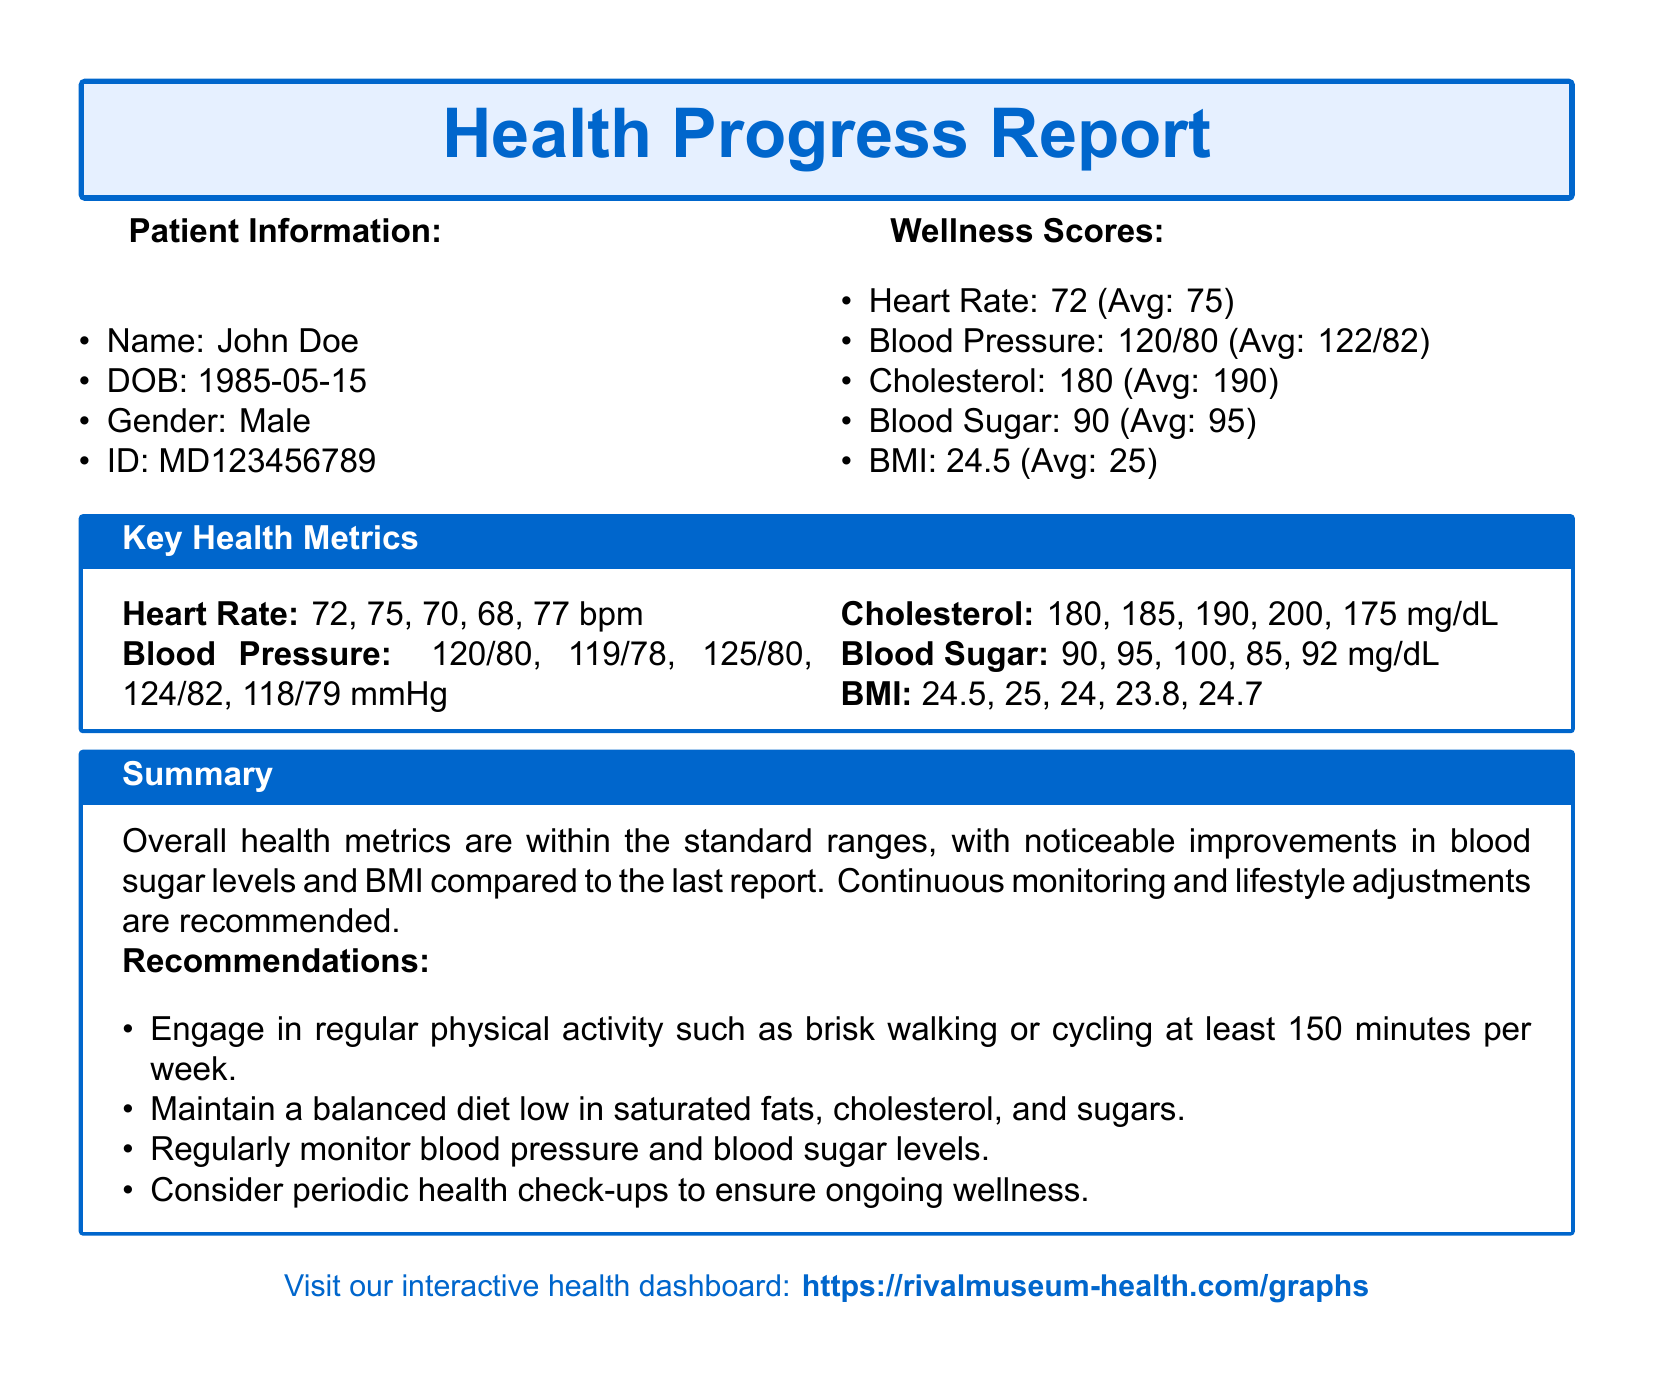What is the patient's name? The patient's name is explicitly stated in the patient information section of the document.
Answer: John Doe What is the patient's date of birth? The date of birth is clearly mentioned in the patient information section.
Answer: 1985-05-15 What is the average heart rate? The average heart rate is provided next to the individual heart rate metric in the wellness scores section.
Answer: 75 What is the cholesterol level? The cholesterol level is given in the wellness scores section of the document.
Answer: 180 Which health metric saw noticeable improvement? The summary section indicates which metrics have improved, requiring reasoning from the information given.
Answer: Blood sugar levels What is recommended physical activity? The recommendations for physical activity are listed in the summary section.
Answer: 150 minutes per week What is the patient's BMI? The BMI is included in the wellness scores section of the report.
Answer: 24.5 What is the blood pressure measurement? The blood pressure reading is noted in the wellness scores section.
Answer: 120/80 What should be monitored regularly? The recommendations section emphasizes the importance of monitoring specific health metrics.
Answer: Blood pressure and blood sugar levels 